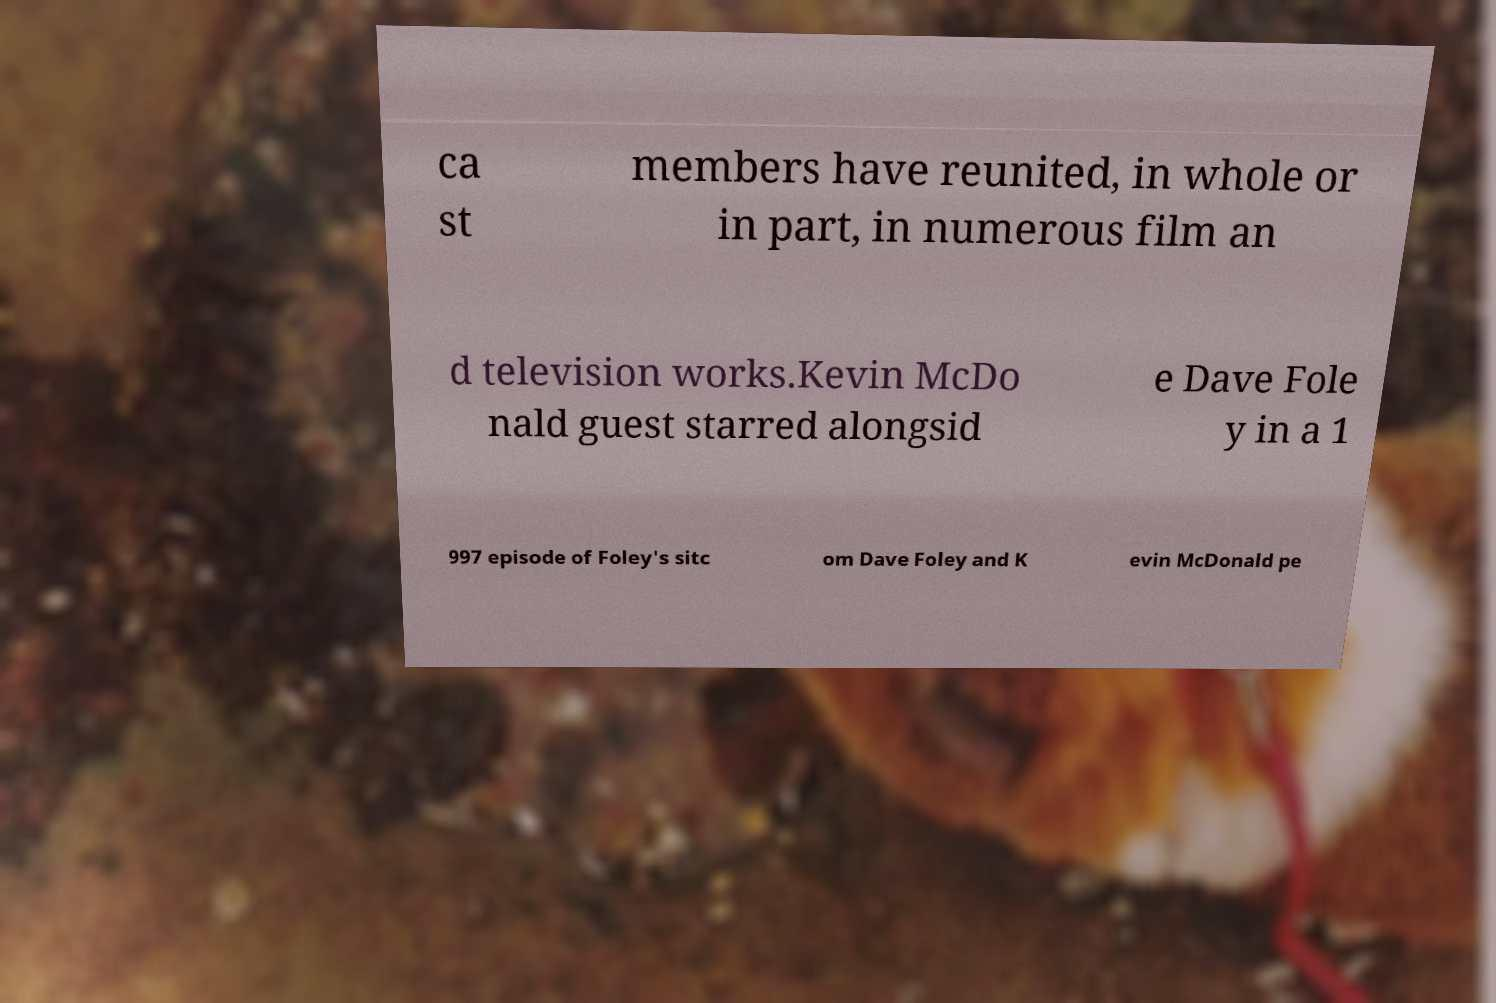Could you extract and type out the text from this image? ca st members have reunited, in whole or in part, in numerous film an d television works.Kevin McDo nald guest starred alongsid e Dave Fole y in a 1 997 episode of Foley's sitc om Dave Foley and K evin McDonald pe 